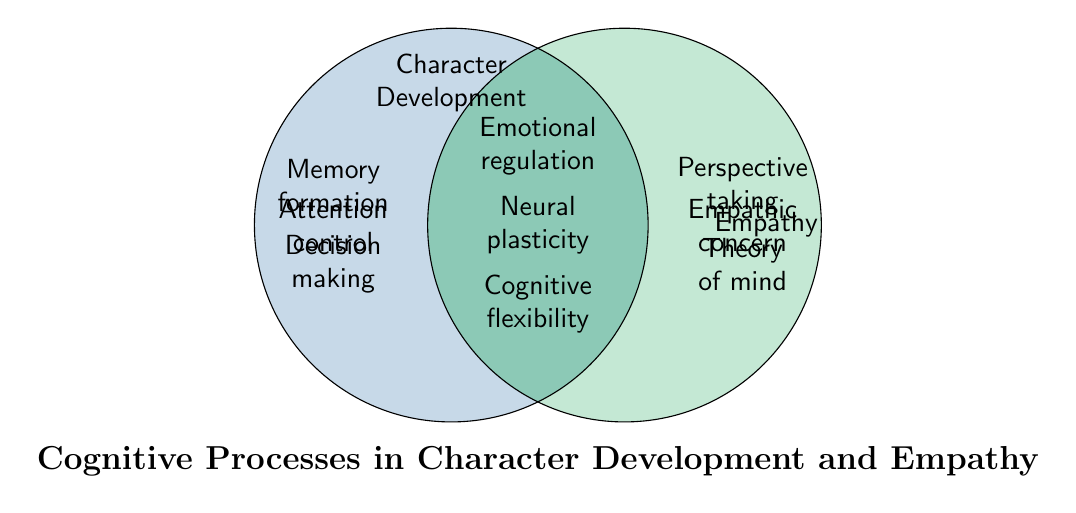What are the two larger sets represented in the Venn Diagram? The two larger sets are labeled as "Character Development" and "Empathy," which are written above the two main circles in the diagram.
Answer: Character Development and Empathy Which cognitive processes are shared between Character Development and Empathy? The shared cognitive processes are listed in the overlapping area of the two circles, including "Emotional regulation," "Neural plasticity," and "Cognitive flexibility."
Answer: Emotional regulation, Neural plasticity, Cognitive flexibility Which cognitive processes are unique to Character Development? The unique cognitive processes for Character Development are listed within the left circle but outside the overlapping area, including "Memory formation," "Decision making," "Attention control," and "Narrative construction."
Answer: Memory formation, Decision making, Attention control, Narrative construction How many cognitive processes are associated with Empathy but not with Character Development? The cognitive processes listed only within the right circle but outside the overlapping area for Empathy are "Perspective taking," "Theory of mind," and "Empathic concern." Counting these gives three cognitive processes.
Answer: 3 Which cognitive process in the Venn Diagram is related to both Character Development and Empathy and involves managing emotions? The cognitive process related to both Character Development and Empathy that involves managing emotions, listed in the overlapping section, is "Emotional regulation."
Answer: Emotional regulation Are there more cognitive processes associated solely with Character Development or solely with Empathy? Count the processes unique to Character Development (Memory formation, Decision making, Attention control, Narrative construction) and those unique to Empathy (Perspective taking, Theory of mind, Empathic concern). Character Development has four, while Empathy has three.
Answer: Character Development What cognitive process relevant to Character Development involves the ability to change and reorganize neural pathways? The cognitive process related to Character Development that involves the ability to change and reorganize neural pathways, listed in the overlapping area, is "Neural plasticity."
Answer: Neural plasticity Which cognitive processes in the diagram contribute to the understanding of others' thoughts and feelings? The cognitive processes contributing to understanding others' thoughts and feelings are listed under Empathy and include "Perspective taking," "Theory of mind," and "Empathic concern."
Answer: Perspective taking, Theory of mind, Empathic concern 